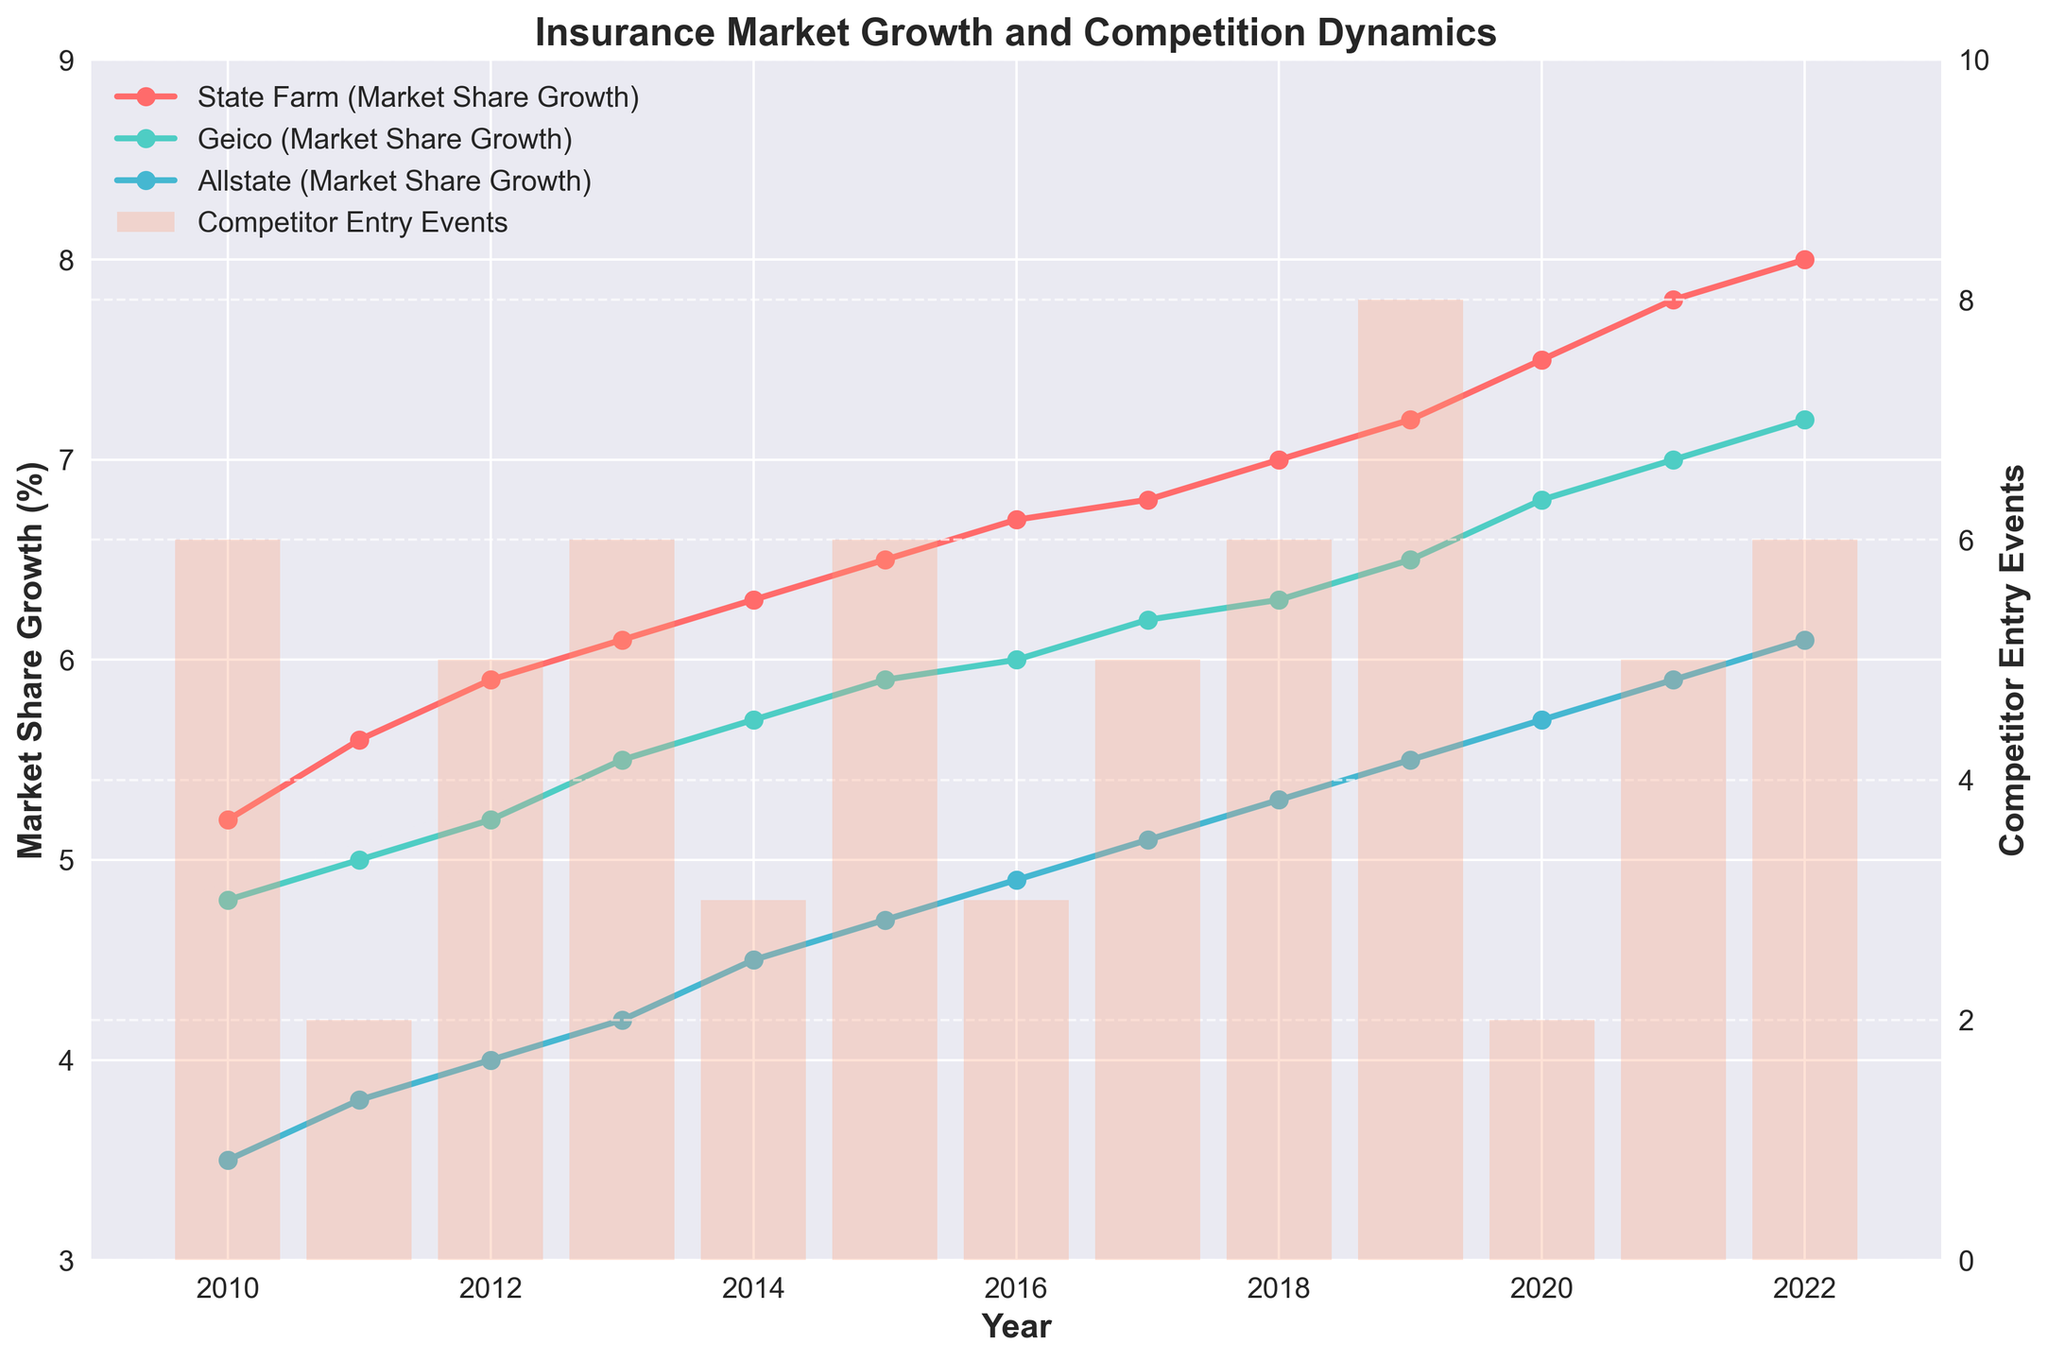What is the highest market share growth percentage for State Farm? By examining the time series plot, locate the highest point on State Farm's (usually colored in a distinct color) line. This should be the peak of the line. On the vertical axis for Market Share Growth (%), note the highest percentage.
Answer: 8.0% How many new policies were sold by Geico in 2018 compared to Allstate in the same year? Locate the points for Geico and Allstate in 2018 on the time series plot. Note down the number of new policies sold from the respective marker on the plot. Subtract Allstate’s number from Geico’s number.
Answer: 20,000 more What is the trend of competitor entry events over the years? Look at the bar graph in the background of the time series plot. Identify the height of the bars year by year to identify the trend. Describe whether the trend of the bars is increasing, decreasing, or consistent across the years.
Answer: Varies; no clear trend In which year did market share growth for Geico surpass that of Allstate? But reviewing the data points for Geico and Allstate, identify the year where Geico's line crosses above Allstate's line. This crossing indicates the surpassing point.
Answer: 2011 How does the number of new policies sold in 2019 compare across the three insurance companies? Locate the 2019 data points for State Farm, Geico, and Allstate. Compare the vertical heights of the markers representing the new policies sold. Identify which company has the highest, the middle, and the lowest number of policies sold.
Answer: State Farm: 590,000; Geico: 570,000; Allstate: 550,000 Which company has the most consistent market share growth over the years? Examine the smoothness and steadiness of the lines representing different companies. Consistency will be indicated by less fluctuation and more linear growth over the years.
Answer: State Farm Was there an increase or decrease in competitor entry events between 2015 and 2016? Determine the height of the bars representing competitor entry events for 2015 and 2016. Compare the heights to see if the bar for 2016 is taller or shorter than the bar for 2015.
Answer: Decrease (3 to 1) What is the relationship between market share growth and competitor entry events for State Farm in 2020? Find the specific year 2020 on the plot and note the market share growth for State Farm. At the same time, check the bar height for competitor entry events in 2020. Correlate if high market share growth coincides with high or low competitor entries.
Answer: Growth: 7.5%, Entries: 1 Which company had the highest market share growth in 2014 and what was the corresponding number of competitor entry events? Identify the highest market share growth among the companies for the year 2014 by comparing the data points. Then, check the bar for the year 2014 to find the corresponding competitor entry events number.
Answer: State Farm with 6.3%, Entries: 1 